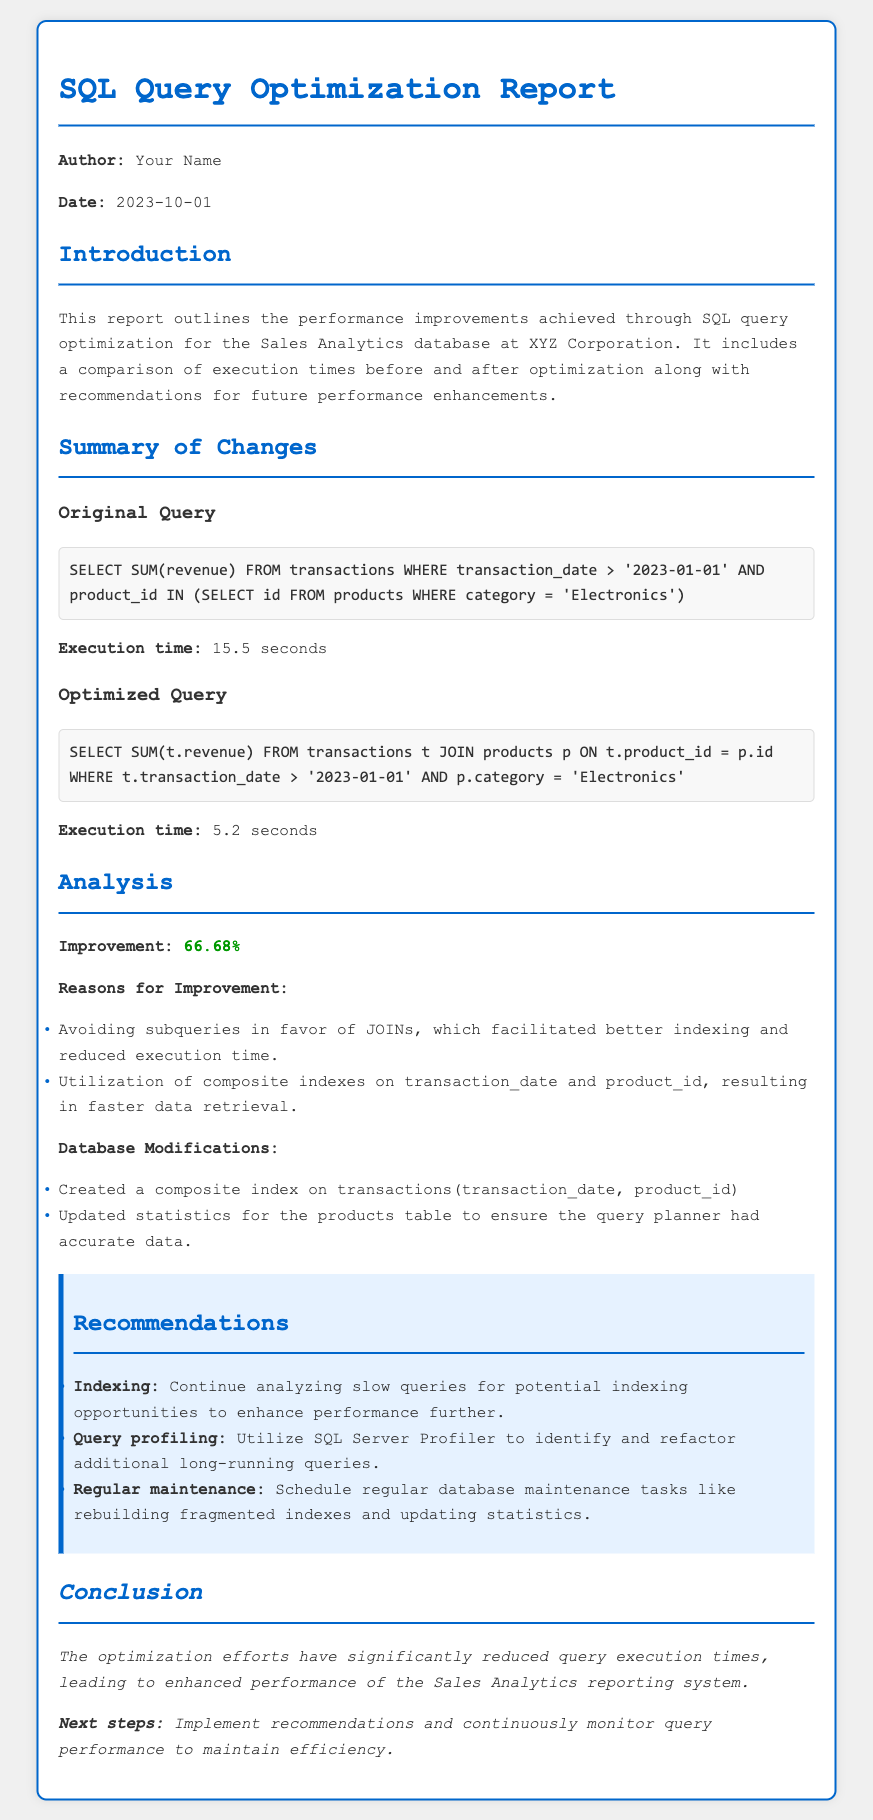What is the execution time of the original query? The execution time of the original query is mentioned directly in the document after the original query section.
Answer: 15.5 seconds What is the execution time of the optimized query? The execution time of the optimized query is mentioned directly in the document after the optimized query section.
Answer: 5.2 seconds What was the percentage improvement in execution time? The improvement percentage is clearly stated in the analysis section of the document.
Answer: 66.68% What are the main reasons for the improvement? The reasons for the improvement are detailed in the analysis section and include specific techniques used.
Answer: Avoiding subqueries, better indexing What composite index was created? The specific composite index that was created is listed in the database modifications section of the document.
Answer: transactions(transaction_date, product_id) What is one recommendation for future performance enhancements? The recommendations section lists various strategies for future enhancements to query performance.
Answer: Indexing What is the date of the report? The date of the report is clearly stated in the document.
Answer: 2023-10-01 What is the title of the document? The title of the document is the main heading stated at the top.
Answer: SQL Query Optimization Report What task should be scheduled regularly according to the recommendations? The recommendations mention several tasks to consider for maintenance, one of which is specified clearly.
Answer: Regular maintenance 